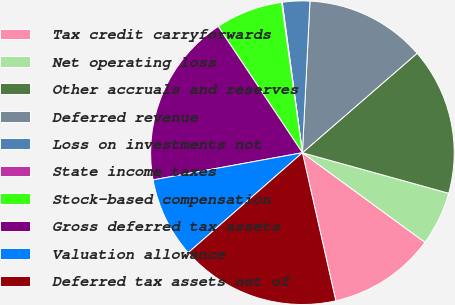Convert chart to OTSL. <chart><loc_0><loc_0><loc_500><loc_500><pie_chart><fcel>Tax credit carryforwards<fcel>Net operating loss<fcel>Other accruals and reserves<fcel>Deferred revenue<fcel>Loss on investments not<fcel>State income taxes<fcel>Stock-based compensation<fcel>Gross deferred tax assets<fcel>Valuation allowance<fcel>Deferred tax assets net of<nl><fcel>11.42%<fcel>5.75%<fcel>15.67%<fcel>12.84%<fcel>2.91%<fcel>0.08%<fcel>7.16%<fcel>18.51%<fcel>8.58%<fcel>17.09%<nl></chart> 